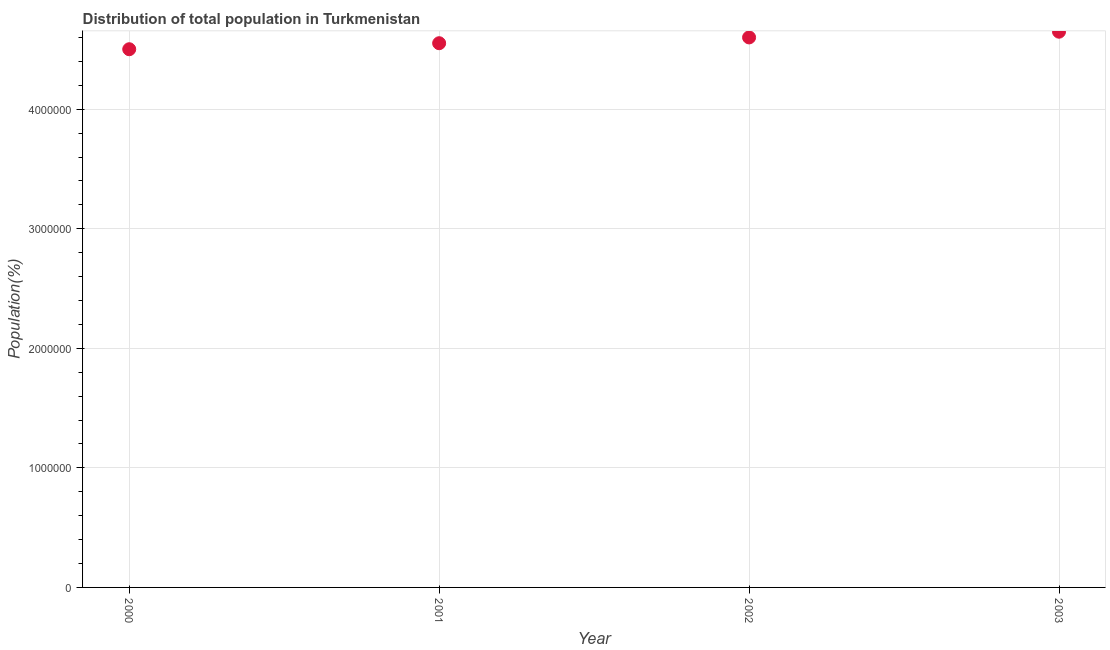What is the population in 2002?
Provide a short and direct response. 4.60e+06. Across all years, what is the maximum population?
Give a very brief answer. 4.65e+06. Across all years, what is the minimum population?
Offer a very short reply. 4.50e+06. In which year was the population maximum?
Your answer should be very brief. 2003. In which year was the population minimum?
Your answer should be compact. 2000. What is the sum of the population?
Offer a terse response. 1.83e+07. What is the difference between the population in 2000 and 2002?
Offer a very short reply. -9.88e+04. What is the average population per year?
Provide a short and direct response. 4.58e+06. What is the median population?
Provide a succinct answer. 4.58e+06. Do a majority of the years between 2001 and 2002 (inclusive) have population greater than 800000 %?
Keep it short and to the point. Yes. What is the ratio of the population in 2000 to that in 2002?
Keep it short and to the point. 0.98. What is the difference between the highest and the second highest population?
Provide a short and direct response. 4.79e+04. Is the sum of the population in 2001 and 2003 greater than the maximum population across all years?
Give a very brief answer. Yes. What is the difference between the highest and the lowest population?
Your response must be concise. 1.47e+05. How many dotlines are there?
Your answer should be very brief. 1. How many years are there in the graph?
Provide a succinct answer. 4. Are the values on the major ticks of Y-axis written in scientific E-notation?
Offer a very short reply. No. What is the title of the graph?
Keep it short and to the point. Distribution of total population in Turkmenistan . What is the label or title of the Y-axis?
Give a very brief answer. Population(%). What is the Population(%) in 2000?
Ensure brevity in your answer.  4.50e+06. What is the Population(%) in 2001?
Your response must be concise. 4.55e+06. What is the Population(%) in 2002?
Offer a very short reply. 4.60e+06. What is the Population(%) in 2003?
Offer a very short reply. 4.65e+06. What is the difference between the Population(%) in 2000 and 2001?
Offer a terse response. -5.03e+04. What is the difference between the Population(%) in 2000 and 2002?
Offer a terse response. -9.88e+04. What is the difference between the Population(%) in 2000 and 2003?
Provide a succinct answer. -1.47e+05. What is the difference between the Population(%) in 2001 and 2002?
Give a very brief answer. -4.84e+04. What is the difference between the Population(%) in 2001 and 2003?
Offer a very short reply. -9.63e+04. What is the difference between the Population(%) in 2002 and 2003?
Give a very brief answer. -4.79e+04. What is the ratio of the Population(%) in 2000 to that in 2001?
Keep it short and to the point. 0.99. What is the ratio of the Population(%) in 2000 to that in 2002?
Give a very brief answer. 0.98. What is the ratio of the Population(%) in 2001 to that in 2003?
Offer a very short reply. 0.98. What is the ratio of the Population(%) in 2002 to that in 2003?
Make the answer very short. 0.99. 